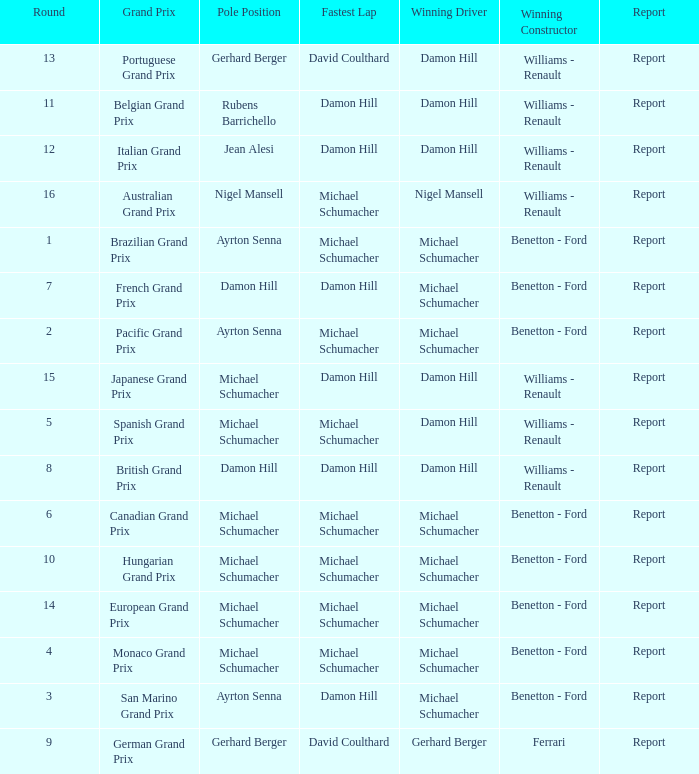Name the fastest lap for the brazilian grand prix Michael Schumacher. Parse the full table. {'header': ['Round', 'Grand Prix', 'Pole Position', 'Fastest Lap', 'Winning Driver', 'Winning Constructor', 'Report'], 'rows': [['13', 'Portuguese Grand Prix', 'Gerhard Berger', 'David Coulthard', 'Damon Hill', 'Williams - Renault', 'Report'], ['11', 'Belgian Grand Prix', 'Rubens Barrichello', 'Damon Hill', 'Damon Hill', 'Williams - Renault', 'Report'], ['12', 'Italian Grand Prix', 'Jean Alesi', 'Damon Hill', 'Damon Hill', 'Williams - Renault', 'Report'], ['16', 'Australian Grand Prix', 'Nigel Mansell', 'Michael Schumacher', 'Nigel Mansell', 'Williams - Renault', 'Report'], ['1', 'Brazilian Grand Prix', 'Ayrton Senna', 'Michael Schumacher', 'Michael Schumacher', 'Benetton - Ford', 'Report'], ['7', 'French Grand Prix', 'Damon Hill', 'Damon Hill', 'Michael Schumacher', 'Benetton - Ford', 'Report'], ['2', 'Pacific Grand Prix', 'Ayrton Senna', 'Michael Schumacher', 'Michael Schumacher', 'Benetton - Ford', 'Report'], ['15', 'Japanese Grand Prix', 'Michael Schumacher', 'Damon Hill', 'Damon Hill', 'Williams - Renault', 'Report'], ['5', 'Spanish Grand Prix', 'Michael Schumacher', 'Michael Schumacher', 'Damon Hill', 'Williams - Renault', 'Report'], ['8', 'British Grand Prix', 'Damon Hill', 'Damon Hill', 'Damon Hill', 'Williams - Renault', 'Report'], ['6', 'Canadian Grand Prix', 'Michael Schumacher', 'Michael Schumacher', 'Michael Schumacher', 'Benetton - Ford', 'Report'], ['10', 'Hungarian Grand Prix', 'Michael Schumacher', 'Michael Schumacher', 'Michael Schumacher', 'Benetton - Ford', 'Report'], ['14', 'European Grand Prix', 'Michael Schumacher', 'Michael Schumacher', 'Michael Schumacher', 'Benetton - Ford', 'Report'], ['4', 'Monaco Grand Prix', 'Michael Schumacher', 'Michael Schumacher', 'Michael Schumacher', 'Benetton - Ford', 'Report'], ['3', 'San Marino Grand Prix', 'Ayrton Senna', 'Damon Hill', 'Michael Schumacher', 'Benetton - Ford', 'Report'], ['9', 'German Grand Prix', 'Gerhard Berger', 'David Coulthard', 'Gerhard Berger', 'Ferrari', 'Report']]} 